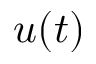<formula> <loc_0><loc_0><loc_500><loc_500>u ( t )</formula> 